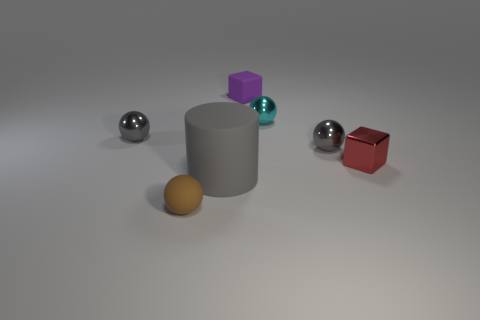Add 1 blue rubber blocks. How many objects exist? 8 Subtract all blocks. How many objects are left? 5 Subtract 0 purple cylinders. How many objects are left? 7 Subtract all purple matte cubes. Subtract all rubber cylinders. How many objects are left? 5 Add 5 matte things. How many matte things are left? 8 Add 1 small cyan cylinders. How many small cyan cylinders exist? 1 